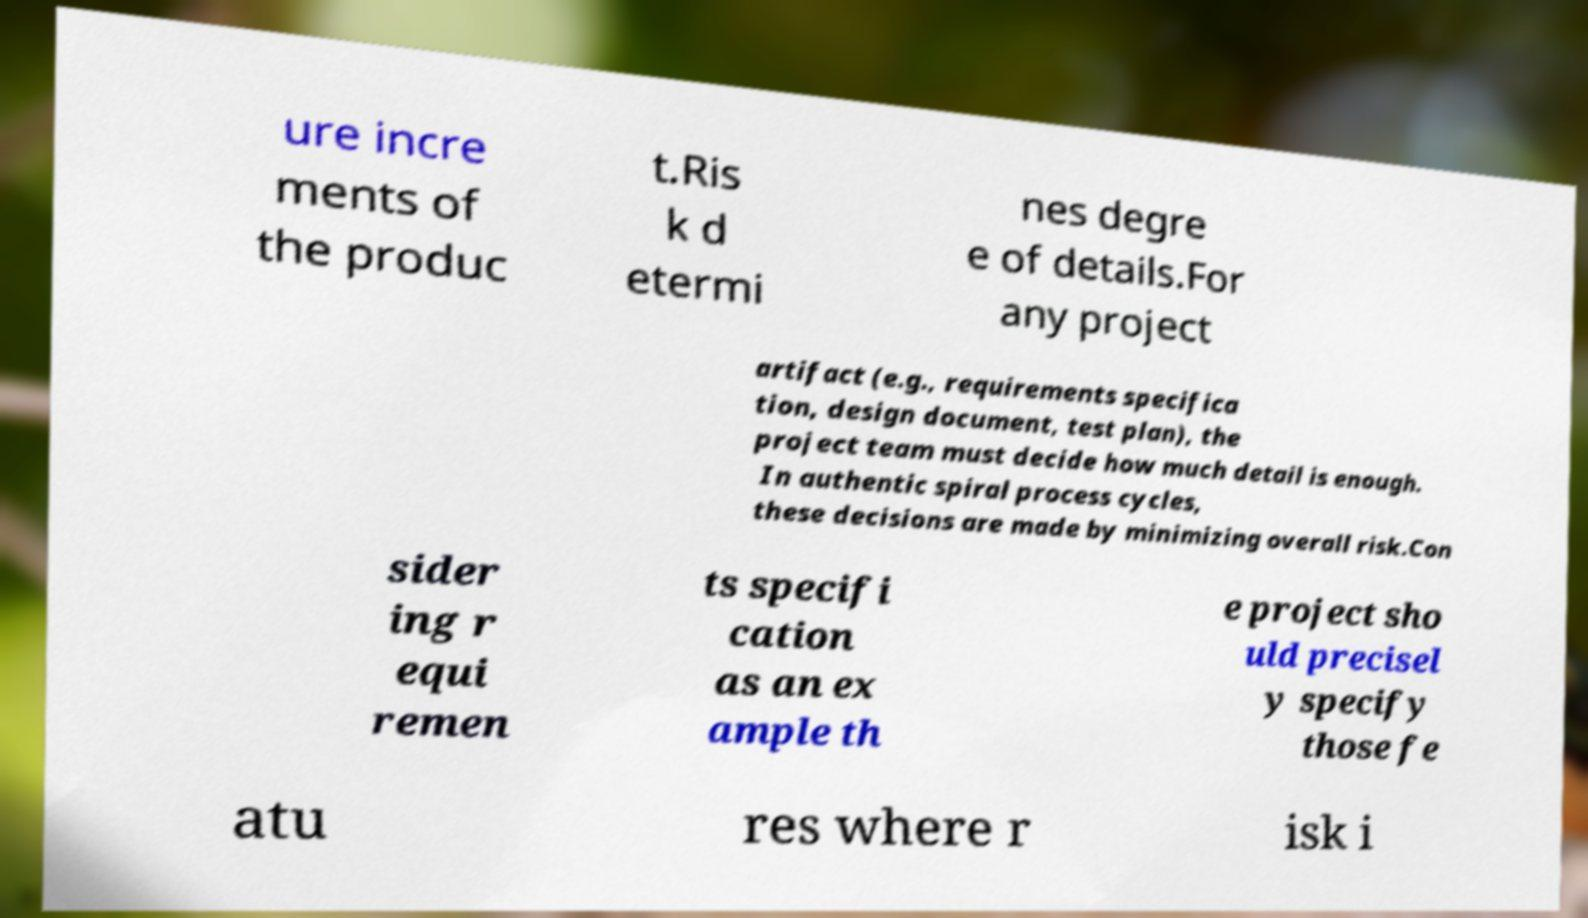Please identify and transcribe the text found in this image. ure incre ments of the produc t.Ris k d etermi nes degre e of details.For any project artifact (e.g., requirements specifica tion, design document, test plan), the project team must decide how much detail is enough. In authentic spiral process cycles, these decisions are made by minimizing overall risk.Con sider ing r equi remen ts specifi cation as an ex ample th e project sho uld precisel y specify those fe atu res where r isk i 